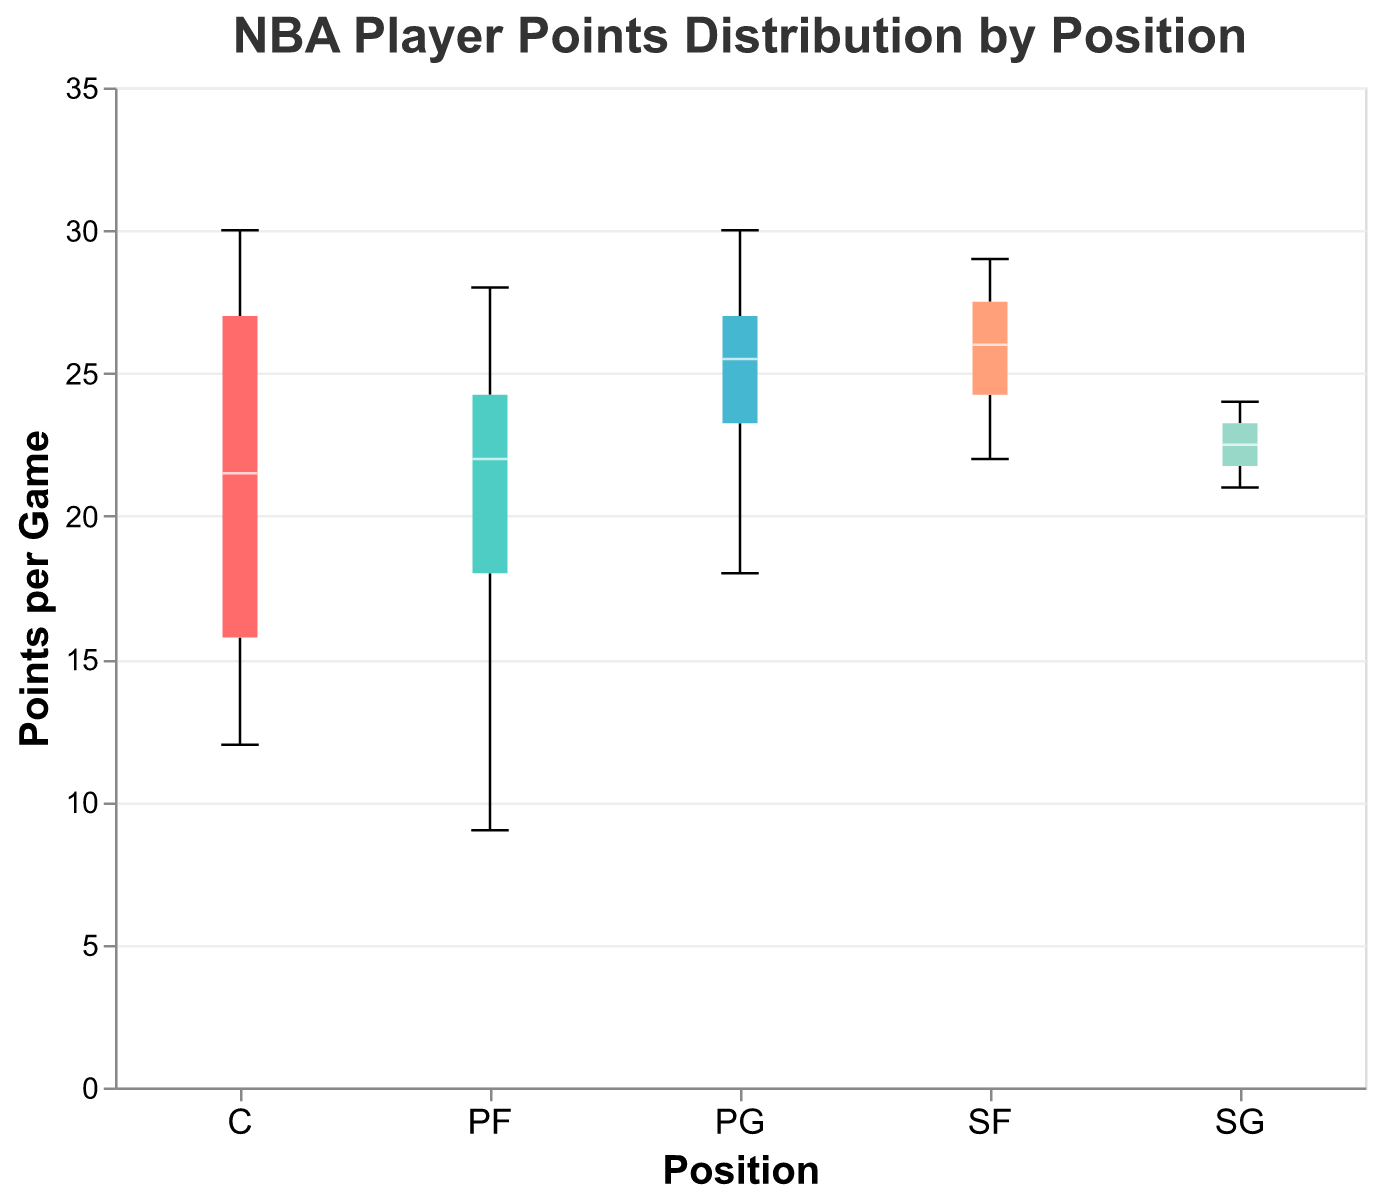What is the title of the plot? The title of the plot is located at the top and reads "NBA Player Points Distribution by Position".
Answer: NBA Player Points Distribution by Position Which position has the highest median points per game? The median points per game for each position can be identified by the white line inside each box in the plot. The position with the highest median point value is at the center of the boxplot for "PG".
Answer: PG What is the range of points for the Center (C) positions? The range of points can be deduced by looking at the upper and lower boundary lines (whiskers) of the boxplot for the Center (C) positions. The range extends from 12 points to 30 points.
Answer: 12 to 30 How does the interquartile range (IQR) of Small Forwards (SF) compare to that of Shooting Guards (SG)? The IQR is represented by the height of the box in each boxplot. Visually compare the boxes for SF and SG. The SF box is taller indicating a larger IQR compared to that of SG.
Answer: SF has a larger IQR What is the minimum points per game for Power Forwards (PF)? The minimum points per game for PF can be identified by the lower boundary line (whisker) of the boxplot for that position, which is at 9 points.
Answer: 9 points What position has the smallest range of points? The range of points for each position can be determined by looking at the distance between the upper and lower boundary lines (whiskers) of each boxplot. The position with the smallest range of points is SG.
Answer: SG Which position has the widest spread of points per game? The spread of points is determined by the distance between the furthest whisker ends. Center (C) has the widest spread, ranging from 12 to 30 points.
Answer: C What is the median point value for the Shooting Guards (SG)? The median point value for SG can be identified by the position of the white line inside the SG box, which is around 22.5 points.
Answer: 22.5 points How many positions have a median point value greater than 25? Examine the white lines inside the boxes for each position and count those with a median value greater than 25 points. There are four such positions: PG, SF, PF, and C.
Answer: 4 Are there any positions where the minimum value is above 10 points? Check the lower whisker lines for each position to see if any of them start above 10 points. PG, SG, SF, and PF all have minimum values above 10 points.
Answer: PG, SG, SF, PF 